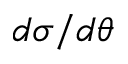Convert formula to latex. <formula><loc_0><loc_0><loc_500><loc_500>d \sigma / d \theta</formula> 